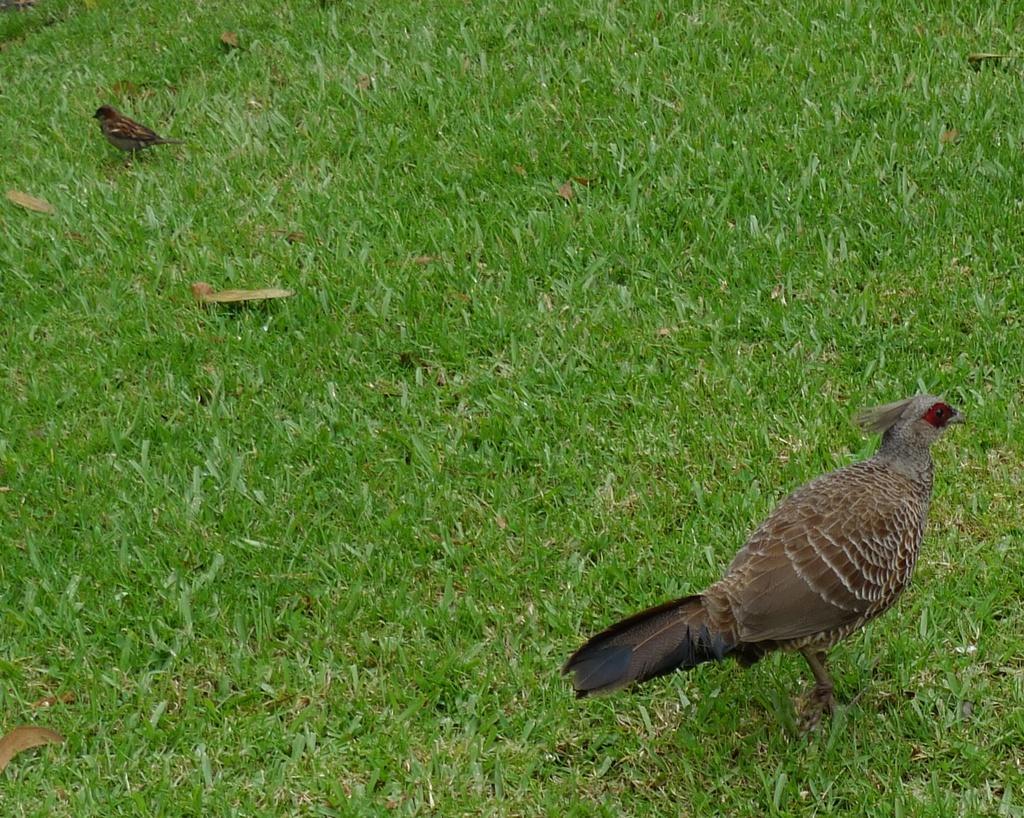In one or two sentences, can you explain what this image depicts? In this image we can see the birds on the ground and also we can see the grass. 